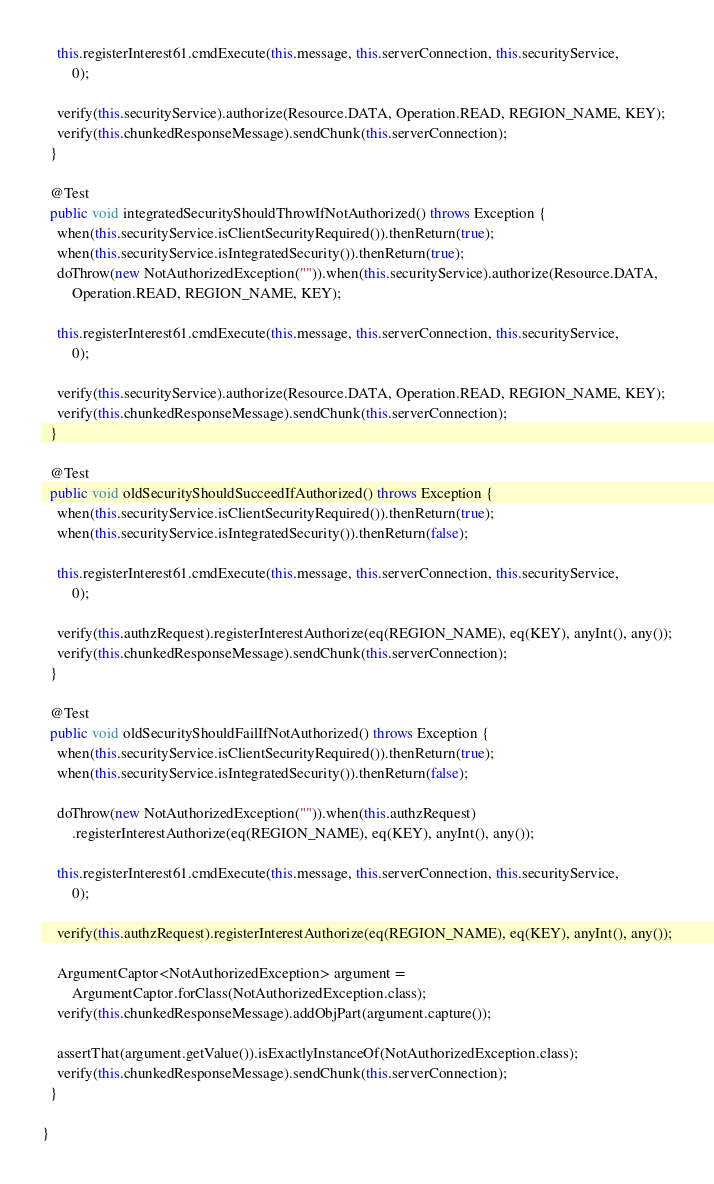<code> <loc_0><loc_0><loc_500><loc_500><_Java_>    this.registerInterest61.cmdExecute(this.message, this.serverConnection, this.securityService,
        0);

    verify(this.securityService).authorize(Resource.DATA, Operation.READ, REGION_NAME, KEY);
    verify(this.chunkedResponseMessage).sendChunk(this.serverConnection);
  }

  @Test
  public void integratedSecurityShouldThrowIfNotAuthorized() throws Exception {
    when(this.securityService.isClientSecurityRequired()).thenReturn(true);
    when(this.securityService.isIntegratedSecurity()).thenReturn(true);
    doThrow(new NotAuthorizedException("")).when(this.securityService).authorize(Resource.DATA,
        Operation.READ, REGION_NAME, KEY);

    this.registerInterest61.cmdExecute(this.message, this.serverConnection, this.securityService,
        0);

    verify(this.securityService).authorize(Resource.DATA, Operation.READ, REGION_NAME, KEY);
    verify(this.chunkedResponseMessage).sendChunk(this.serverConnection);
  }

  @Test
  public void oldSecurityShouldSucceedIfAuthorized() throws Exception {
    when(this.securityService.isClientSecurityRequired()).thenReturn(true);
    when(this.securityService.isIntegratedSecurity()).thenReturn(false);

    this.registerInterest61.cmdExecute(this.message, this.serverConnection, this.securityService,
        0);

    verify(this.authzRequest).registerInterestAuthorize(eq(REGION_NAME), eq(KEY), anyInt(), any());
    verify(this.chunkedResponseMessage).sendChunk(this.serverConnection);
  }

  @Test
  public void oldSecurityShouldFailIfNotAuthorized() throws Exception {
    when(this.securityService.isClientSecurityRequired()).thenReturn(true);
    when(this.securityService.isIntegratedSecurity()).thenReturn(false);

    doThrow(new NotAuthorizedException("")).when(this.authzRequest)
        .registerInterestAuthorize(eq(REGION_NAME), eq(KEY), anyInt(), any());

    this.registerInterest61.cmdExecute(this.message, this.serverConnection, this.securityService,
        0);

    verify(this.authzRequest).registerInterestAuthorize(eq(REGION_NAME), eq(KEY), anyInt(), any());

    ArgumentCaptor<NotAuthorizedException> argument =
        ArgumentCaptor.forClass(NotAuthorizedException.class);
    verify(this.chunkedResponseMessage).addObjPart(argument.capture());

    assertThat(argument.getValue()).isExactlyInstanceOf(NotAuthorizedException.class);
    verify(this.chunkedResponseMessage).sendChunk(this.serverConnection);
  }

}
</code> 